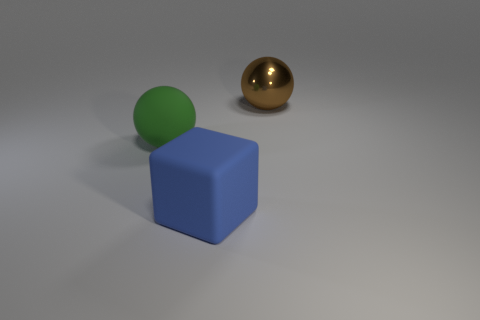Add 2 tiny gray rubber things. How many objects exist? 5 Subtract 1 blocks. How many blocks are left? 0 Subtract all balls. How many objects are left? 1 Add 3 large matte balls. How many large matte balls are left? 4 Add 2 green matte balls. How many green matte balls exist? 3 Subtract all green spheres. How many spheres are left? 1 Subtract 0 cyan cylinders. How many objects are left? 3 Subtract all brown cubes. Subtract all purple balls. How many cubes are left? 1 Subtract all brown cubes. How many green balls are left? 1 Subtract all metal spheres. Subtract all small blue matte balls. How many objects are left? 2 